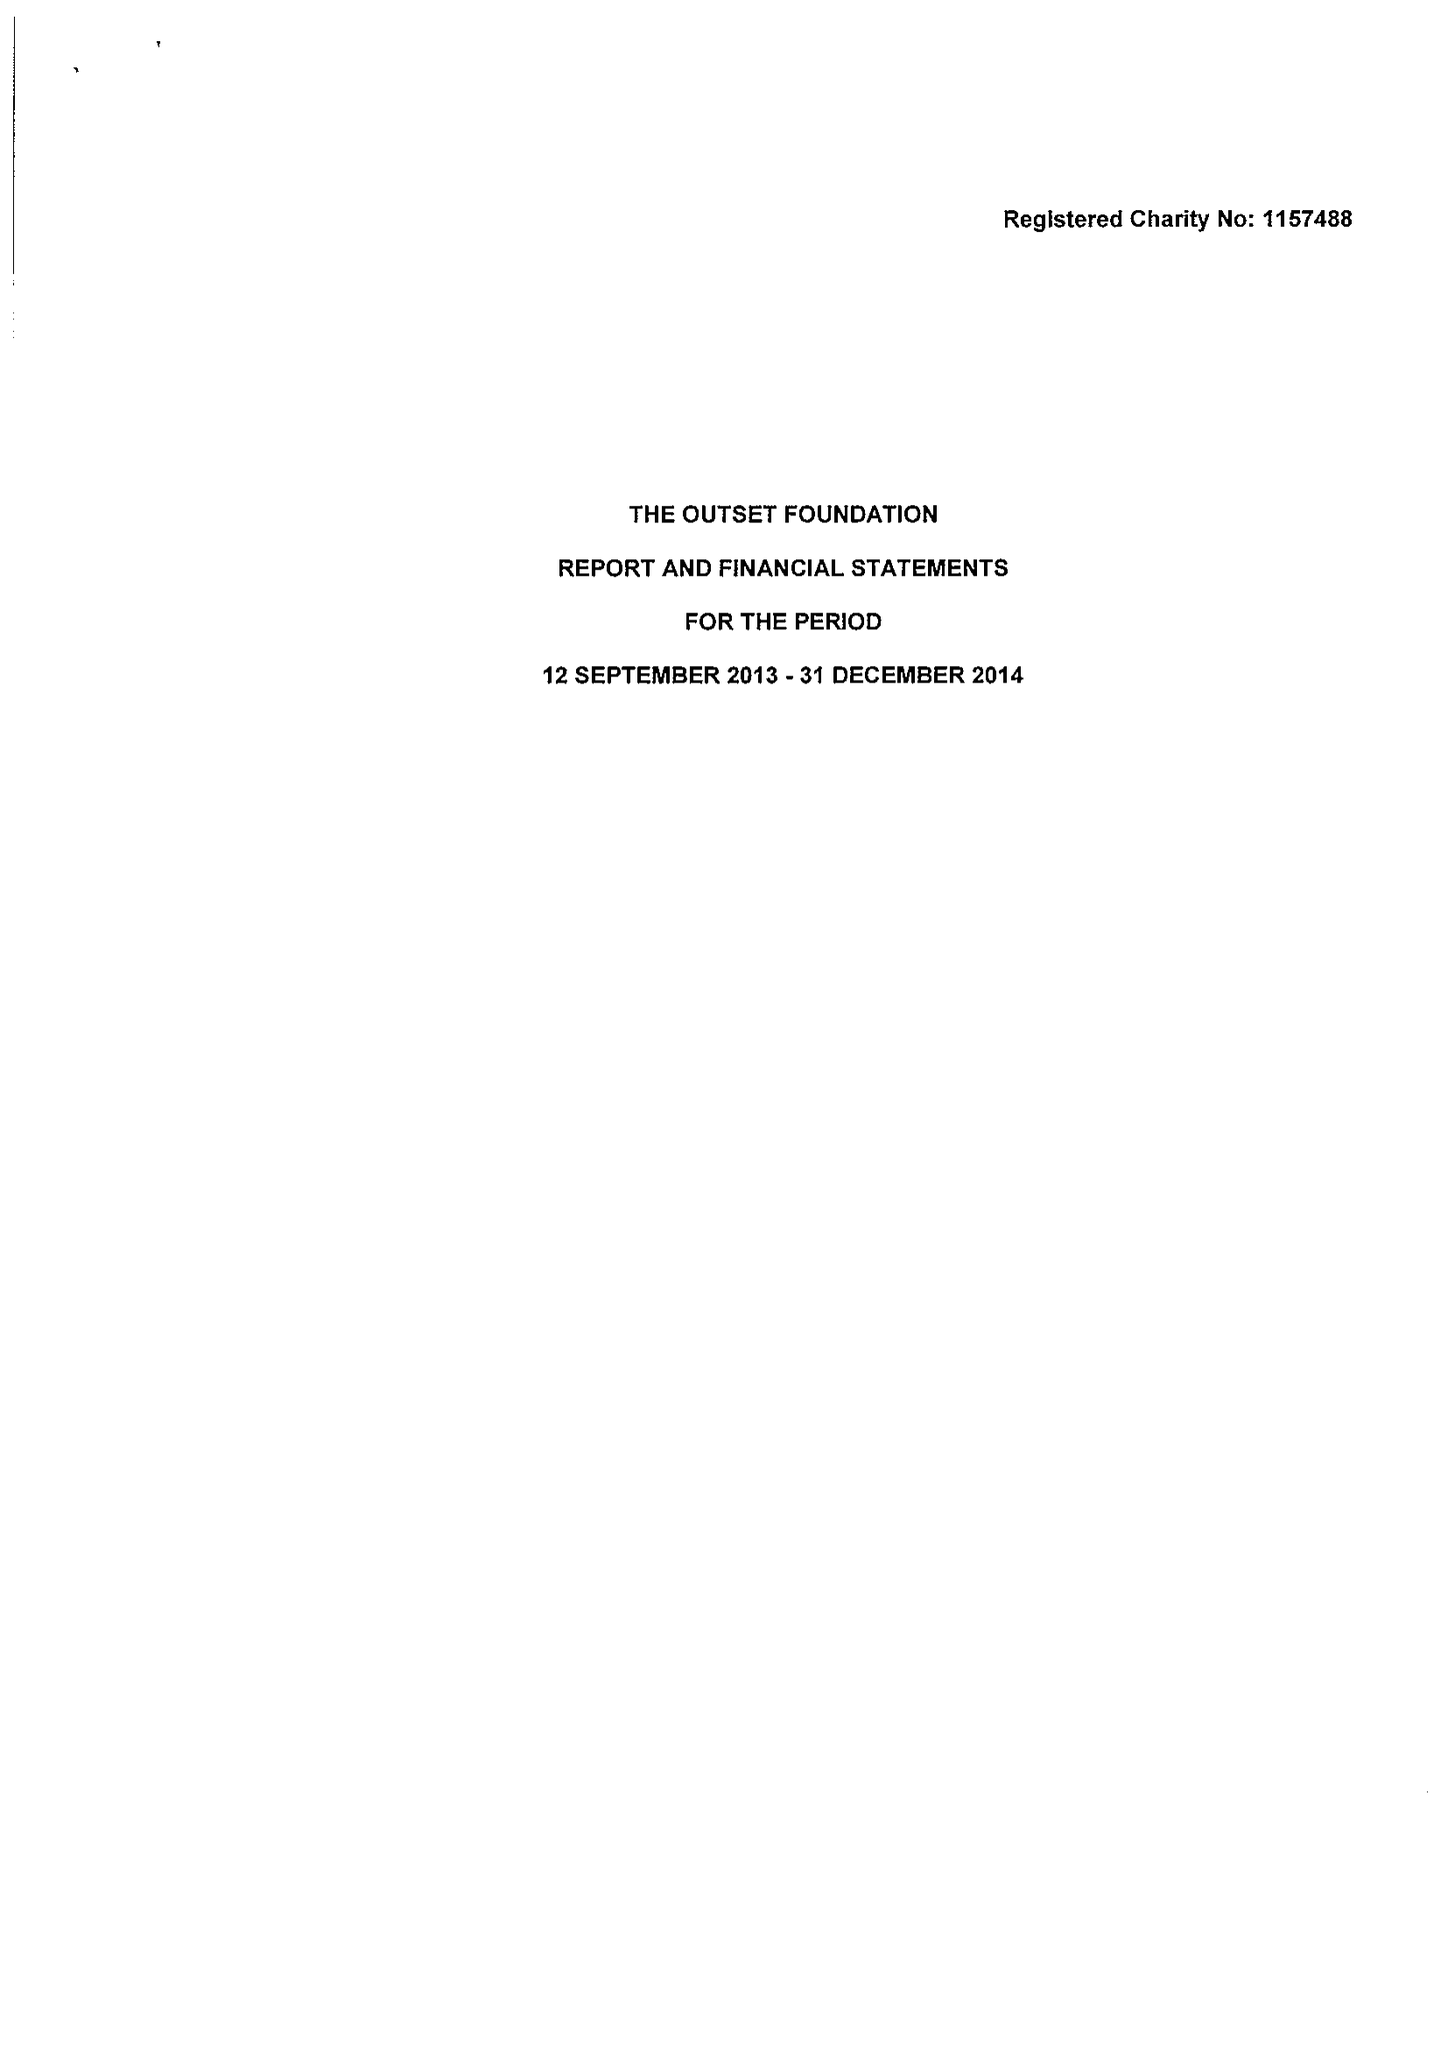What is the value for the address__post_town?
Answer the question using a single word or phrase. CAMBRIDGE 